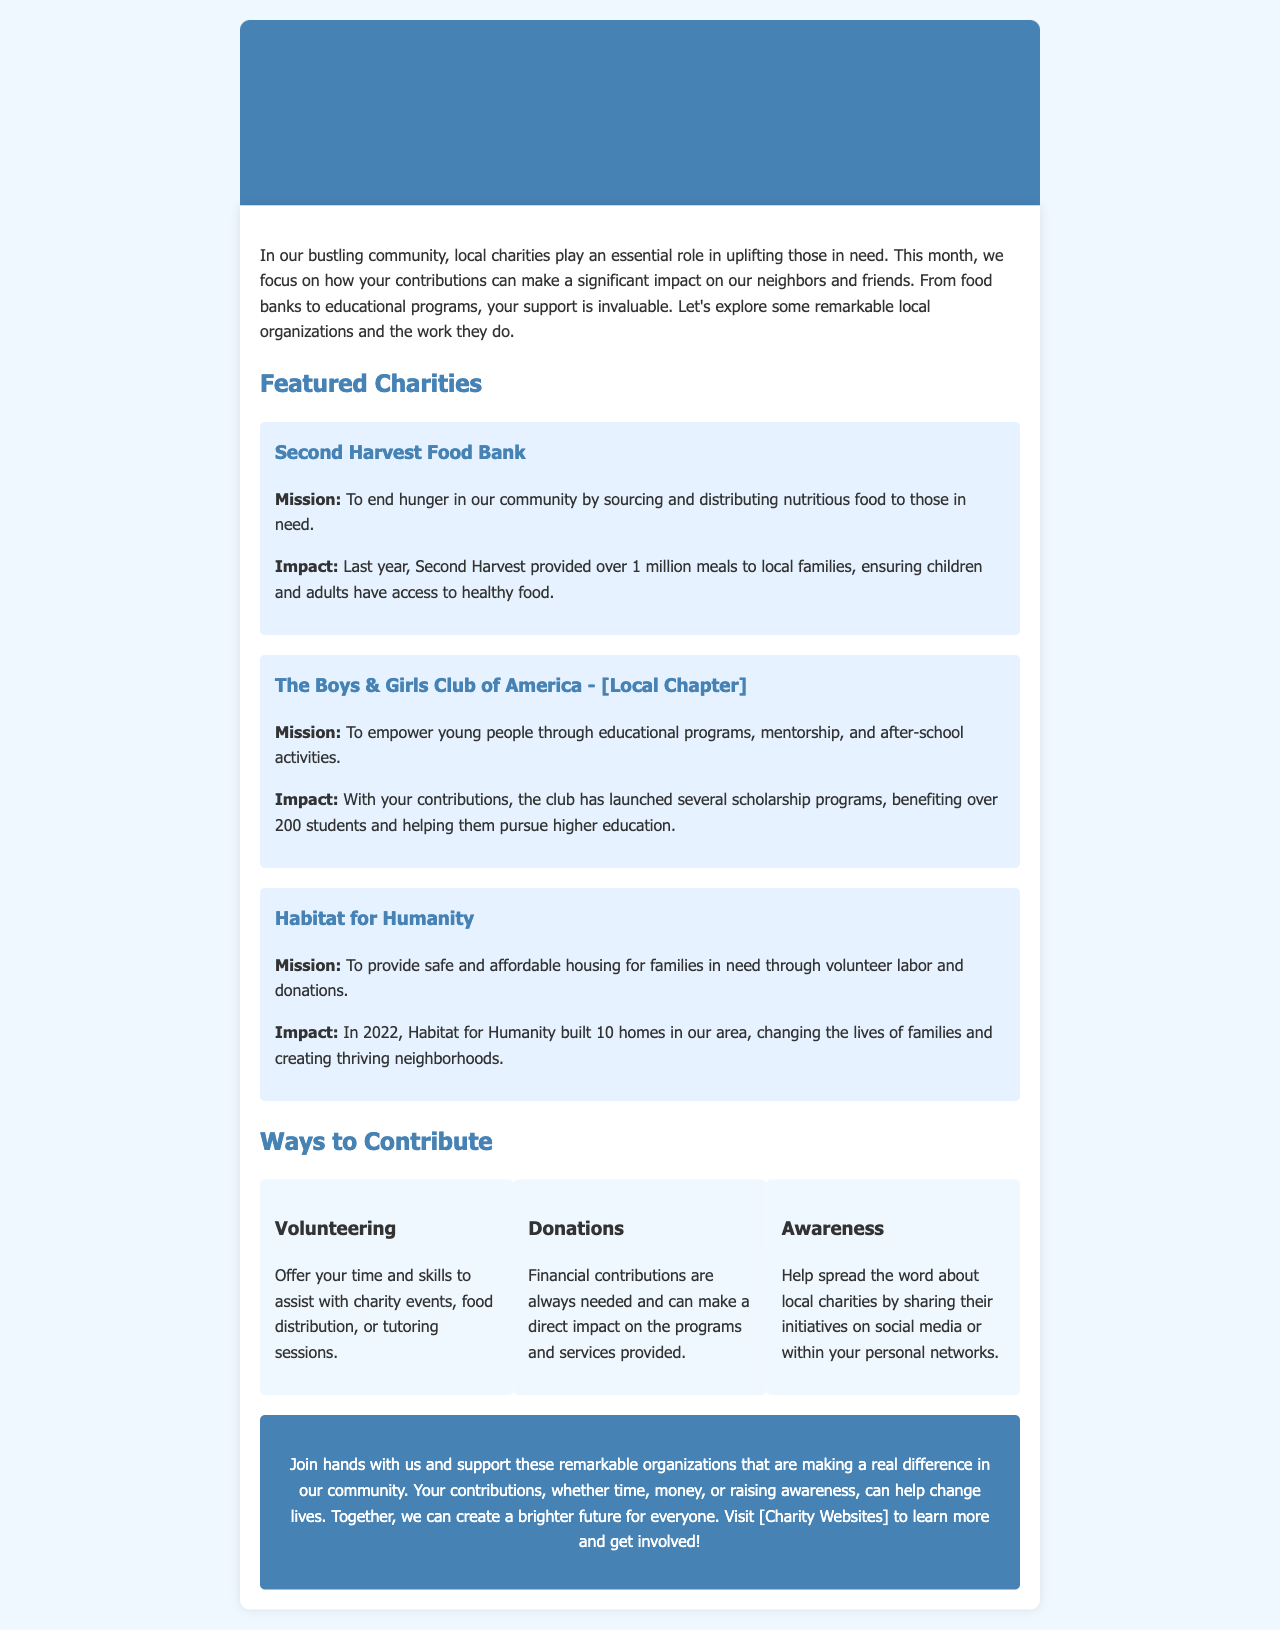What is the mission of Second Harvest Food Bank? The mission of Second Harvest Food Bank is to end hunger in our community by sourcing and distributing nutritious food to those in need.
Answer: To end hunger in our community by sourcing and distributing nutritious food to those in need How many meals did Second Harvest provide last year? The document states that Second Harvest provided over 1 million meals to local families last year.
Answer: Over 1 million meals How many students benefited from the scholarship programs of The Boys & Girls Club? The document indicates that over 200 students benefited from the scholarship programs launched by The Boys & Girls Club.
Answer: Over 200 students How many homes did Habitat for Humanity build in 2022? The document specifies that Habitat for Humanity built 10 homes in our area in 2022.
Answer: 10 homes What is one way to contribute mentioned in the document? The document lists volunteering, donations, and awareness as ways to contribute.
Answer: Volunteering Which charity focuses on providing safe and affordable housing? The charity that focuses on providing safe and affordable housing is Habitat for Humanity.
Answer: Habitat for Humanity What is the purpose of the call to action at the end of the document? The purpose of the call to action is to encourage readers to support local charities and contribute in various ways.
Answer: To encourage support for local charities What color is the header background? The background color of the header is #4682b4.
Answer: #4682b4 What is the focus of this month's newsletter? This month's newsletter focuses on how community contributions can make a significant impact on local charities.
Answer: Community contributions making a significant impact on local charities 